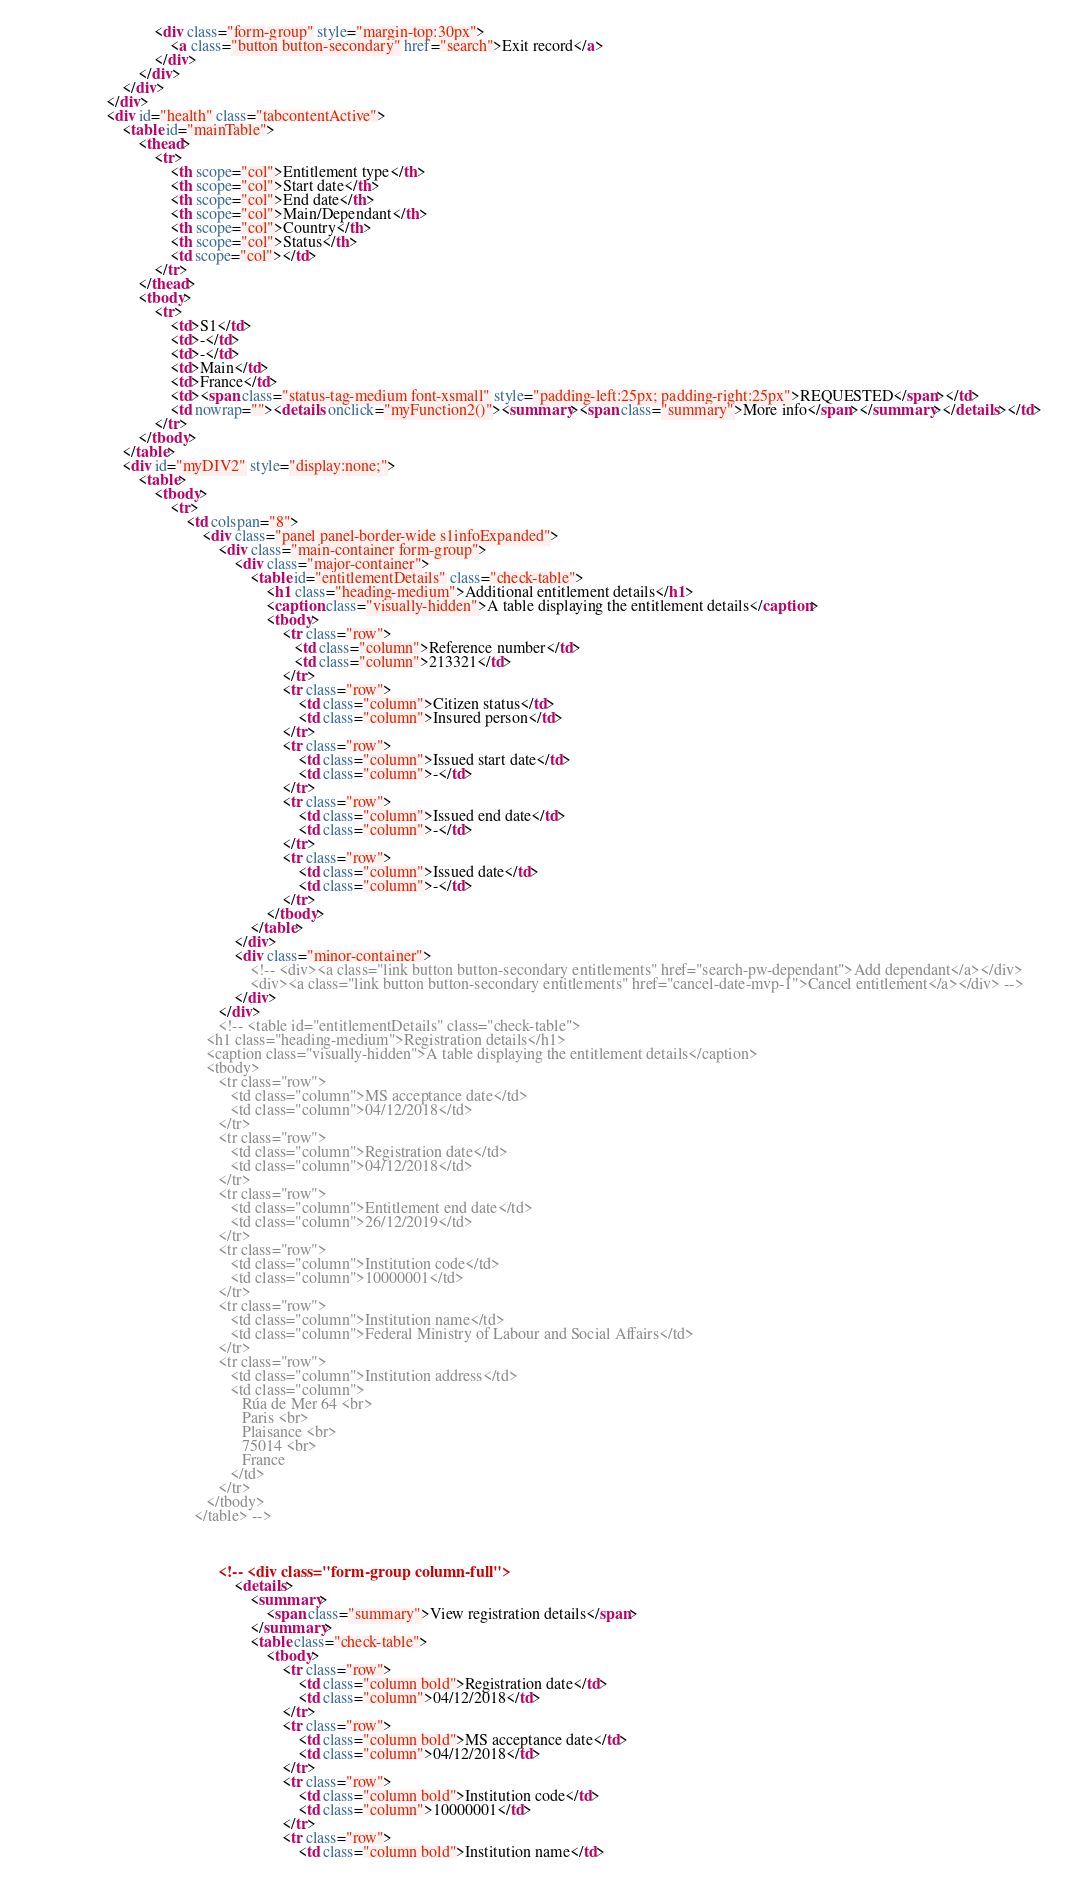Convert code to text. <code><loc_0><loc_0><loc_500><loc_500><_HTML_>								<div class="form-group" style="margin-top:30px">
									<a class="button button-secondary" href="search">Exit record</a>
								</div>
							</div>
						</div>
					</div>
					<div id="health" class="tabcontentActive">
						<table id="mainTable">
							<thead>
								<tr>
									<th scope="col">Entitlement type</th>
									<th scope="col">Start date</th>
									<th scope="col">End date</th>
									<th scope="col">Main/Dependant</th>
									<th scope="col">Country</th>
									<th scope="col">Status</th>
									<td scope="col"></td>
								</tr>
							</thead>
							<tbody>
								<tr>
									<td>S1</td>
									<td>-</td>
									<td>-</td>
									<td>Main</td>
									<td>France</td>
									<td><span class="status-tag-medium font-xsmall" style="padding-left:25px; padding-right:25px">REQUESTED</span></td>
									<td nowrap=""><details onclick="myFunction2()"><summary><span class="summary">More info</span></summary></details></td>
								</tr>
							</tbody>
						</table>
						<div id="myDIV2" style="display:none;">
							<table>
								<tbody>
									<tr>
										<td colspan="8">
											<div class="panel panel-border-wide s1infoExpanded">
												<div class="main-container form-group">
													<div class="major-container">
														<table id="entitlementDetails" class="check-table">
															<h1 class="heading-medium">Additional entitlement details</h1>
															<caption class="visually-hidden">A table displaying the entitlement details</caption>
															<tbody>
																<tr class="row">
				                                                   <td class="column">Reference number</td>
				                                                   <td class="column">213321</td>
				                                                </tr>
																<tr class="row">
																	<td class="column">Citizen status</td>
																	<td class="column">Insured person</td>
																</tr>
																<tr class="row">
																	<td class="column">Issued start date</td>
																	<td class="column">-</td>
																</tr>
																<tr class="row">
																	<td class="column">Issued end date</td>
																	<td class="column">-</td>
																</tr>
																<tr class="row">
																	<td class="column">Issued date</td>
																	<td class="column">-</td>
																</tr>
															</tbody>
														</table>
													</div>
													<div class="minor-container">
														<!-- <div><a class="link button button-secondary entitlements" href="search-pw-dependant">Add dependant</a></div>
														<div><a class="link button button-secondary entitlements" href="cancel-date-mvp-1">Cancel entitlement</a></div> -->
													</div>
												</div>
												<!-- <table id="entitlementDetails" class="check-table">
                                             <h1 class="heading-medium">Registration details</h1>
                                             <caption class="visually-hidden">A table displaying the entitlement details</caption>
                                             <tbody>
                                                <tr class="row">
                                                   <td class="column">MS acceptance date</td>
                                                   <td class="column">04/12/2018</td>
                                                </tr>
                                                <tr class="row">
                                                   <td class="column">Registration date</td>
                                                   <td class="column">04/12/2018</td>
                                                </tr>
                                                <tr class="row">
                                                   <td class="column">Entitlement end date</td>
                                                   <td class="column">26/12/2019</td>
                                                </tr>
                                                <tr class="row">
                                                   <td class="column">Institution code</td>
                                                   <td class="column">10000001</td>
                                                </tr>
                                                <tr class="row">
                                                   <td class="column">Institution name</td>
                                                   <td class="column">Federal Ministry of Labour and Social Affairs</td>
                                                </tr>
                                                <tr class="row">
                                                   <td class="column">Institution address</td>
                                                   <td class="column">
                                                      Rúa de Mer 64 <br>
                                                      Paris <br>
                                                      Plaisance <br>
                                                      75014 <br>
                                                      France
                                                   </td>
                                                </tr>
                                             </tbody>
                                          </table> -->



												<!-- <div class="form-group column-full">
													<details>
														<summary>
															<span class="summary">View registration details</span>
														</summary>
														<table class="check-table">
															<tbody>
																<tr class="row">
																	<td class="column bold">Registration date</td>
																	<td class="column">04/12/2018</td>
																</tr>
																<tr class="row">
																	<td class="column bold">MS acceptance date</td>
																	<td class="column">04/12/2018</td>
																</tr>
																<tr class="row">
																	<td class="column bold">Institution code</td>
																	<td class="column">10000001</td>
																</tr>
																<tr class="row">
																	<td class="column bold">Institution name</td></code> 